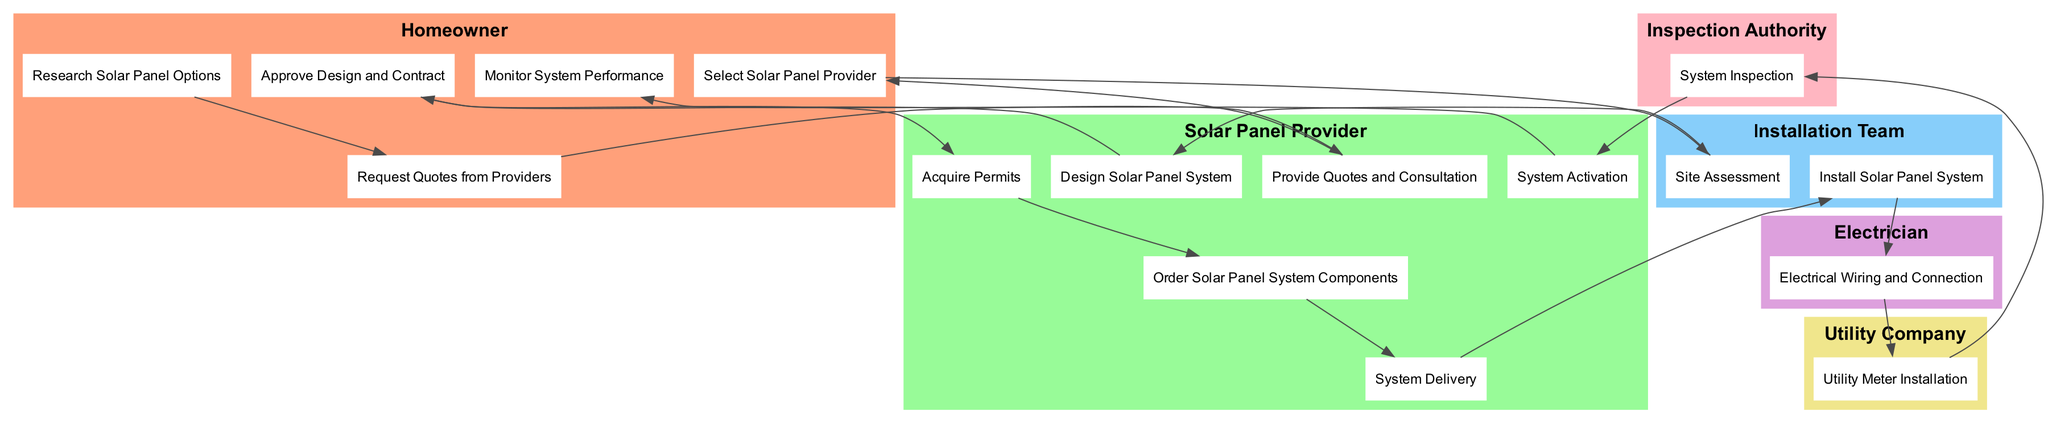What is the first activity the Homeowner performs? The diagram indicates the first activity in the flow for the Homeowner is "Research Solar Panel Options." This is the initial step that starts the installation workflow.
Answer: Research Solar Panel Options How many roles are involved in the installation workflow? The diagram lists six distinct roles: Homeowner, Solar Panel Provider, Installation Team, Electrician, Utility Company, and Inspection Authority. This is a count based on the number of unique roles represented in the diagram.
Answer: Six Which role is responsible for the "System Activation" activity? The diagram shows that the "System Activation" activity is performed by the Solar Panel Provider. This can be confirmed by identifying the role linked to that specific activity within the diagram.
Answer: Solar Panel Provider What activity follows "Approve Design and Contract"? According to the flow of activities in the diagram, "Acquire Permits" comes immediately after "Approve Design and Contract." This follows the sequence outlined in the activity diagram.
Answer: Acquire Permits How many total activities are shown in the diagram? The diagram details a total of 15 specific activities that take place in the installation workflow. This can be determined by counting all the nodes representing distinct activities.
Answer: Fifteen Which two roles are involved in the "Install Solar Panel System" activity? The diagram shows that the "Install Solar Panel System" is carried out by the Installation Team, and it likely involves oversight from the Solar Panel Provider as well, which can be inferred from the previous steps related to this activity. Therefore, the two roles are Installation Team and Solar Panel Provider.
Answer: Installation Team and Solar Panel Provider What is the last activity shown in the workflow? The final activity presented in the diagram is "Monitor System Performance," which is the concluding task a Homeowner undertakes after the setup of the solar panel system is complete.
Answer: Monitor System Performance Which activity comes immediately before "Electrical Wiring and Connection"? The flow indicates that "Install Solar Panel System" takes place right before "Electrical Wiring and Connection." Observing the sequence of activities in the diagram shows this transition clearly.
Answer: Install Solar Panel System Which role is primarily responsible for conducting the "System Inspection"? The diagram specifies that the "Inspection Authority" is responsible for conducting the "System Inspection." This can be traced directly from the activity node associated with this role in the diagram.
Answer: Inspection Authority 